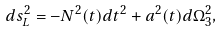Convert formula to latex. <formula><loc_0><loc_0><loc_500><loc_500>d s _ { L } ^ { 2 } = - N ^ { 2 } ( t ) d t ^ { 2 } + a ^ { 2 } ( t ) d \Omega ^ { 2 } _ { 3 } ,</formula> 